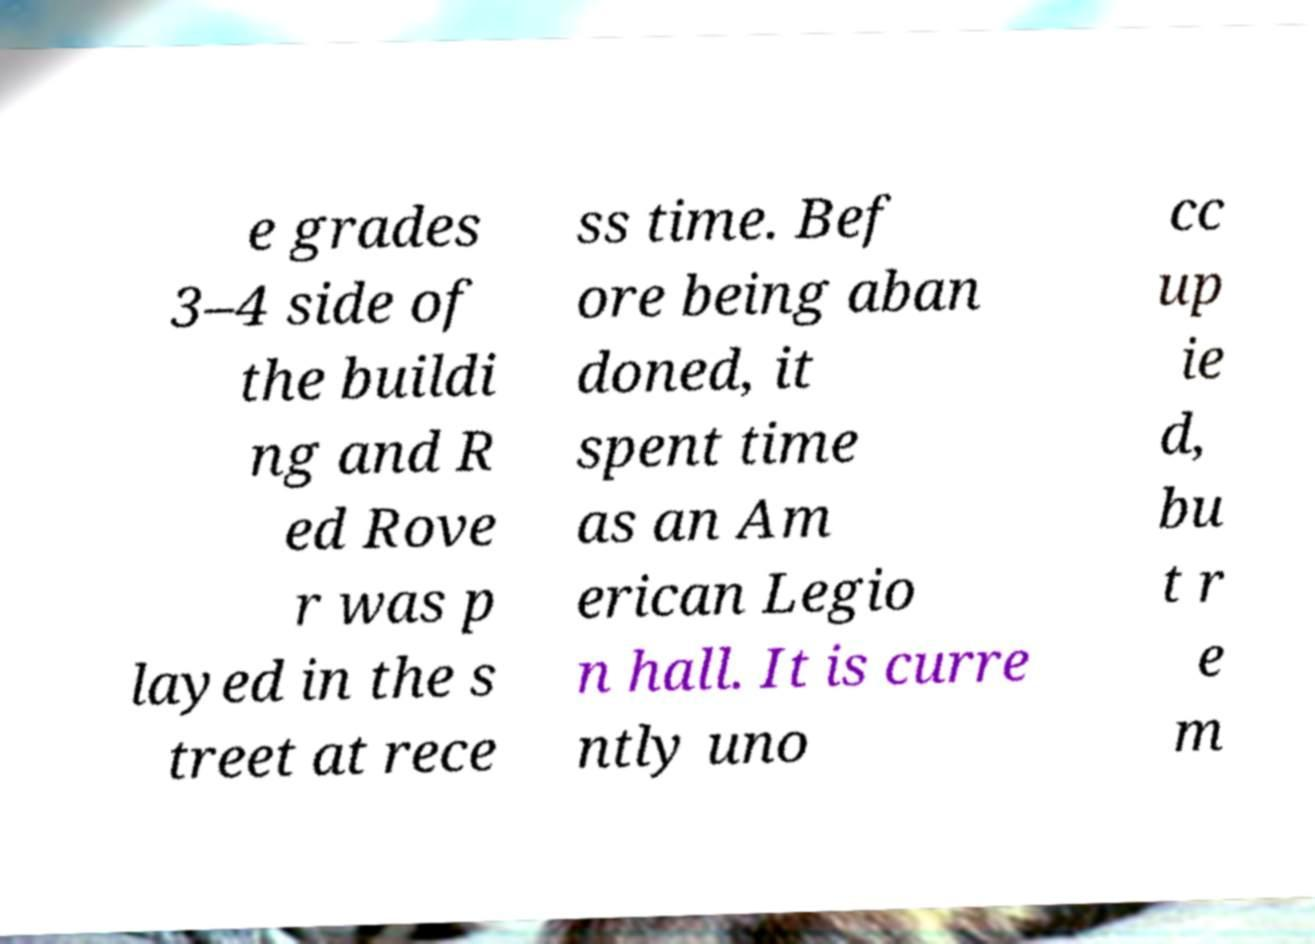Please identify and transcribe the text found in this image. e grades 3–4 side of the buildi ng and R ed Rove r was p layed in the s treet at rece ss time. Bef ore being aban doned, it spent time as an Am erican Legio n hall. It is curre ntly uno cc up ie d, bu t r e m 